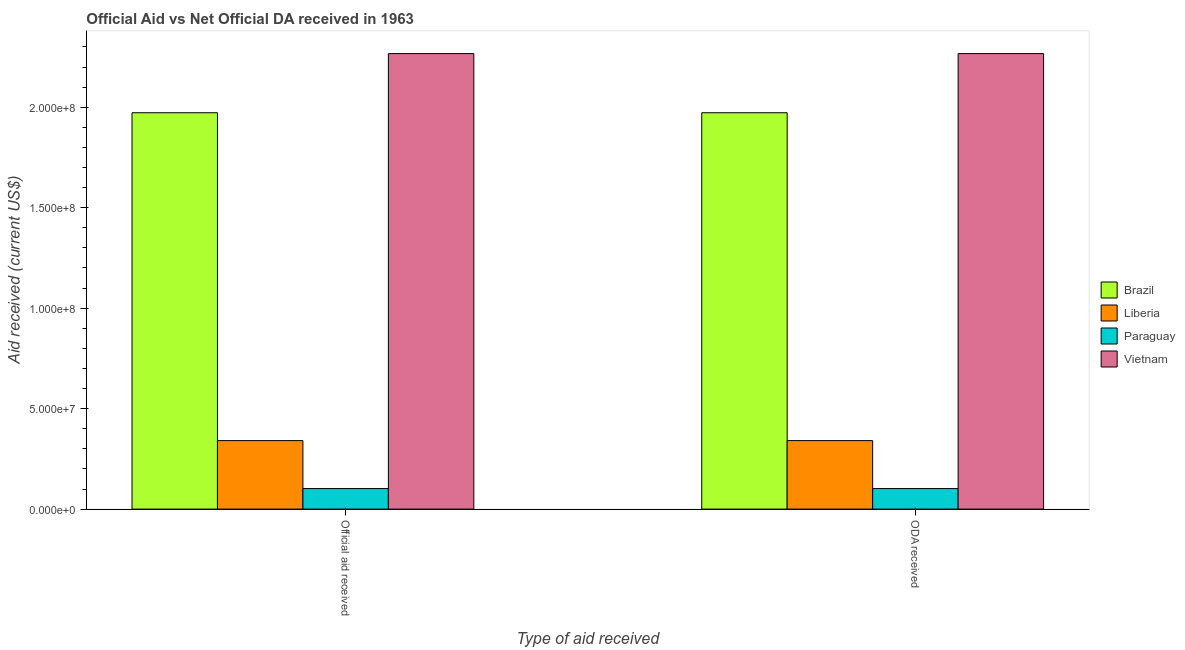How many different coloured bars are there?
Offer a terse response. 4. How many groups of bars are there?
Give a very brief answer. 2. Are the number of bars per tick equal to the number of legend labels?
Make the answer very short. Yes. How many bars are there on the 2nd tick from the right?
Give a very brief answer. 4. What is the label of the 1st group of bars from the left?
Ensure brevity in your answer.  Official aid received. What is the oda received in Brazil?
Offer a terse response. 1.97e+08. Across all countries, what is the maximum official aid received?
Your answer should be very brief. 2.27e+08. Across all countries, what is the minimum oda received?
Your answer should be compact. 1.02e+07. In which country was the oda received maximum?
Keep it short and to the point. Vietnam. In which country was the official aid received minimum?
Your answer should be compact. Paraguay. What is the total oda received in the graph?
Your response must be concise. 4.68e+08. What is the difference between the official aid received in Liberia and that in Brazil?
Keep it short and to the point. -1.63e+08. What is the difference between the official aid received in Paraguay and the oda received in Vietnam?
Make the answer very short. -2.16e+08. What is the average oda received per country?
Give a very brief answer. 1.17e+08. What is the difference between the oda received and official aid received in Vietnam?
Make the answer very short. 0. In how many countries, is the oda received greater than 20000000 US$?
Keep it short and to the point. 3. What is the ratio of the official aid received in Liberia to that in Paraguay?
Your answer should be compact. 3.34. What does the 2nd bar from the right in ODA received represents?
Give a very brief answer. Paraguay. Are all the bars in the graph horizontal?
Your answer should be compact. No. How many countries are there in the graph?
Make the answer very short. 4. What is the difference between two consecutive major ticks on the Y-axis?
Make the answer very short. 5.00e+07. Does the graph contain any zero values?
Ensure brevity in your answer.  No. Where does the legend appear in the graph?
Ensure brevity in your answer.  Center right. How many legend labels are there?
Your response must be concise. 4. How are the legend labels stacked?
Ensure brevity in your answer.  Vertical. What is the title of the graph?
Give a very brief answer. Official Aid vs Net Official DA received in 1963 . What is the label or title of the X-axis?
Offer a terse response. Type of aid received. What is the label or title of the Y-axis?
Offer a terse response. Aid received (current US$). What is the Aid received (current US$) of Brazil in Official aid received?
Offer a very short reply. 1.97e+08. What is the Aid received (current US$) in Liberia in Official aid received?
Your answer should be very brief. 3.41e+07. What is the Aid received (current US$) of Paraguay in Official aid received?
Offer a terse response. 1.02e+07. What is the Aid received (current US$) in Vietnam in Official aid received?
Offer a terse response. 2.27e+08. What is the Aid received (current US$) in Brazil in ODA received?
Your response must be concise. 1.97e+08. What is the Aid received (current US$) in Liberia in ODA received?
Provide a succinct answer. 3.41e+07. What is the Aid received (current US$) of Paraguay in ODA received?
Your answer should be very brief. 1.02e+07. What is the Aid received (current US$) of Vietnam in ODA received?
Provide a succinct answer. 2.27e+08. Across all Type of aid received, what is the maximum Aid received (current US$) of Brazil?
Offer a terse response. 1.97e+08. Across all Type of aid received, what is the maximum Aid received (current US$) of Liberia?
Keep it short and to the point. 3.41e+07. Across all Type of aid received, what is the maximum Aid received (current US$) in Paraguay?
Offer a very short reply. 1.02e+07. Across all Type of aid received, what is the maximum Aid received (current US$) of Vietnam?
Give a very brief answer. 2.27e+08. Across all Type of aid received, what is the minimum Aid received (current US$) of Brazil?
Ensure brevity in your answer.  1.97e+08. Across all Type of aid received, what is the minimum Aid received (current US$) in Liberia?
Ensure brevity in your answer.  3.41e+07. Across all Type of aid received, what is the minimum Aid received (current US$) of Paraguay?
Offer a very short reply. 1.02e+07. Across all Type of aid received, what is the minimum Aid received (current US$) in Vietnam?
Your answer should be very brief. 2.27e+08. What is the total Aid received (current US$) in Brazil in the graph?
Offer a terse response. 3.94e+08. What is the total Aid received (current US$) of Liberia in the graph?
Your response must be concise. 6.82e+07. What is the total Aid received (current US$) in Paraguay in the graph?
Provide a succinct answer. 2.04e+07. What is the total Aid received (current US$) of Vietnam in the graph?
Provide a short and direct response. 4.53e+08. What is the difference between the Aid received (current US$) in Brazil in Official aid received and that in ODA received?
Your response must be concise. 0. What is the difference between the Aid received (current US$) in Paraguay in Official aid received and that in ODA received?
Keep it short and to the point. 0. What is the difference between the Aid received (current US$) in Vietnam in Official aid received and that in ODA received?
Keep it short and to the point. 0. What is the difference between the Aid received (current US$) of Brazil in Official aid received and the Aid received (current US$) of Liberia in ODA received?
Keep it short and to the point. 1.63e+08. What is the difference between the Aid received (current US$) in Brazil in Official aid received and the Aid received (current US$) in Paraguay in ODA received?
Ensure brevity in your answer.  1.87e+08. What is the difference between the Aid received (current US$) of Brazil in Official aid received and the Aid received (current US$) of Vietnam in ODA received?
Keep it short and to the point. -2.94e+07. What is the difference between the Aid received (current US$) in Liberia in Official aid received and the Aid received (current US$) in Paraguay in ODA received?
Provide a short and direct response. 2.39e+07. What is the difference between the Aid received (current US$) in Liberia in Official aid received and the Aid received (current US$) in Vietnam in ODA received?
Provide a succinct answer. -1.93e+08. What is the difference between the Aid received (current US$) of Paraguay in Official aid received and the Aid received (current US$) of Vietnam in ODA received?
Offer a very short reply. -2.16e+08. What is the average Aid received (current US$) in Brazil per Type of aid received?
Offer a very short reply. 1.97e+08. What is the average Aid received (current US$) in Liberia per Type of aid received?
Offer a terse response. 3.41e+07. What is the average Aid received (current US$) of Paraguay per Type of aid received?
Your response must be concise. 1.02e+07. What is the average Aid received (current US$) in Vietnam per Type of aid received?
Your response must be concise. 2.27e+08. What is the difference between the Aid received (current US$) in Brazil and Aid received (current US$) in Liberia in Official aid received?
Give a very brief answer. 1.63e+08. What is the difference between the Aid received (current US$) in Brazil and Aid received (current US$) in Paraguay in Official aid received?
Provide a short and direct response. 1.87e+08. What is the difference between the Aid received (current US$) in Brazil and Aid received (current US$) in Vietnam in Official aid received?
Your answer should be compact. -2.94e+07. What is the difference between the Aid received (current US$) in Liberia and Aid received (current US$) in Paraguay in Official aid received?
Make the answer very short. 2.39e+07. What is the difference between the Aid received (current US$) in Liberia and Aid received (current US$) in Vietnam in Official aid received?
Give a very brief answer. -1.93e+08. What is the difference between the Aid received (current US$) in Paraguay and Aid received (current US$) in Vietnam in Official aid received?
Offer a terse response. -2.16e+08. What is the difference between the Aid received (current US$) of Brazil and Aid received (current US$) of Liberia in ODA received?
Keep it short and to the point. 1.63e+08. What is the difference between the Aid received (current US$) of Brazil and Aid received (current US$) of Paraguay in ODA received?
Offer a terse response. 1.87e+08. What is the difference between the Aid received (current US$) in Brazil and Aid received (current US$) in Vietnam in ODA received?
Ensure brevity in your answer.  -2.94e+07. What is the difference between the Aid received (current US$) in Liberia and Aid received (current US$) in Paraguay in ODA received?
Your response must be concise. 2.39e+07. What is the difference between the Aid received (current US$) in Liberia and Aid received (current US$) in Vietnam in ODA received?
Offer a very short reply. -1.93e+08. What is the difference between the Aid received (current US$) in Paraguay and Aid received (current US$) in Vietnam in ODA received?
Give a very brief answer. -2.16e+08. What is the ratio of the Aid received (current US$) of Brazil in Official aid received to that in ODA received?
Provide a succinct answer. 1. What is the ratio of the Aid received (current US$) of Liberia in Official aid received to that in ODA received?
Give a very brief answer. 1. What is the ratio of the Aid received (current US$) in Vietnam in Official aid received to that in ODA received?
Provide a succinct answer. 1. What is the difference between the highest and the second highest Aid received (current US$) in Brazil?
Your response must be concise. 0. What is the difference between the highest and the second highest Aid received (current US$) in Paraguay?
Offer a terse response. 0. What is the difference between the highest and the second highest Aid received (current US$) of Vietnam?
Make the answer very short. 0. What is the difference between the highest and the lowest Aid received (current US$) of Liberia?
Your response must be concise. 0. What is the difference between the highest and the lowest Aid received (current US$) in Paraguay?
Your response must be concise. 0. What is the difference between the highest and the lowest Aid received (current US$) in Vietnam?
Offer a terse response. 0. 